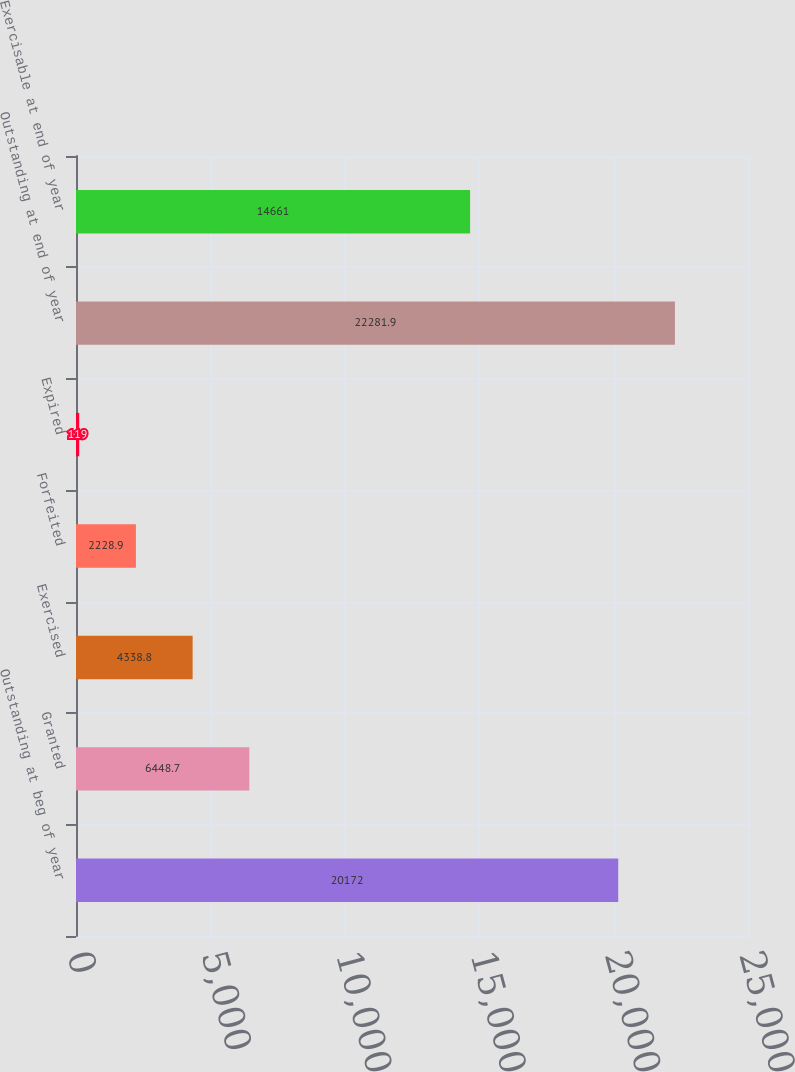Convert chart. <chart><loc_0><loc_0><loc_500><loc_500><bar_chart><fcel>Outstanding at beg of year<fcel>Granted<fcel>Exercised<fcel>Forfeited<fcel>Expired<fcel>Outstanding at end of year<fcel>Exercisable at end of year<nl><fcel>20172<fcel>6448.7<fcel>4338.8<fcel>2228.9<fcel>119<fcel>22281.9<fcel>14661<nl></chart> 